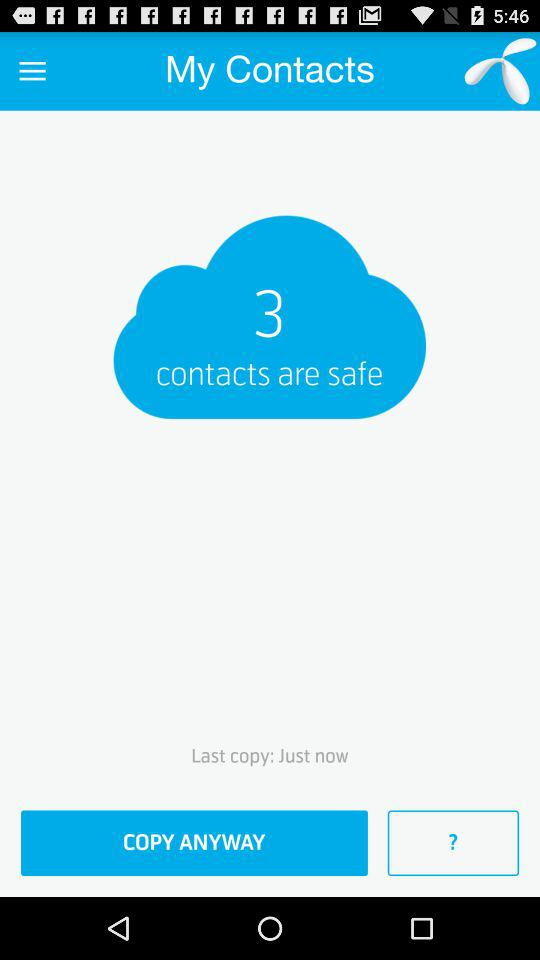At what time was the last copy made? The last copy was made just now. 